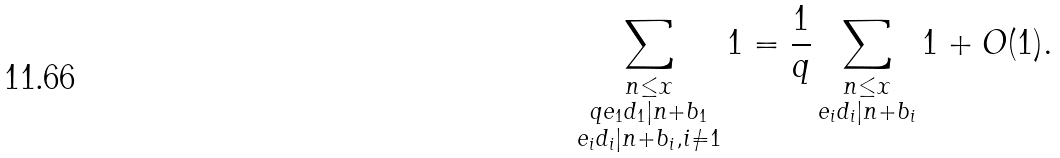Convert formula to latex. <formula><loc_0><loc_0><loc_500><loc_500>\sum _ { \substack { n \leq x \\ q e _ { 1 } d _ { 1 } | n + b _ { 1 } \\ e _ { i } d _ { i } | n + b _ { i } , i \neq 1 } } 1 = \frac { 1 } { q } \sum _ { \substack { n \leq x \\ e _ { i } d _ { i } | n + b _ { i } } } 1 + O ( 1 ) .</formula> 